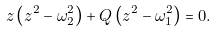Convert formula to latex. <formula><loc_0><loc_0><loc_500><loc_500>z \left ( z ^ { 2 } - \omega _ { 2 } ^ { 2 } \right ) + Q \left ( z ^ { 2 } - \omega _ { 1 } ^ { 2 } \right ) = 0 .</formula> 